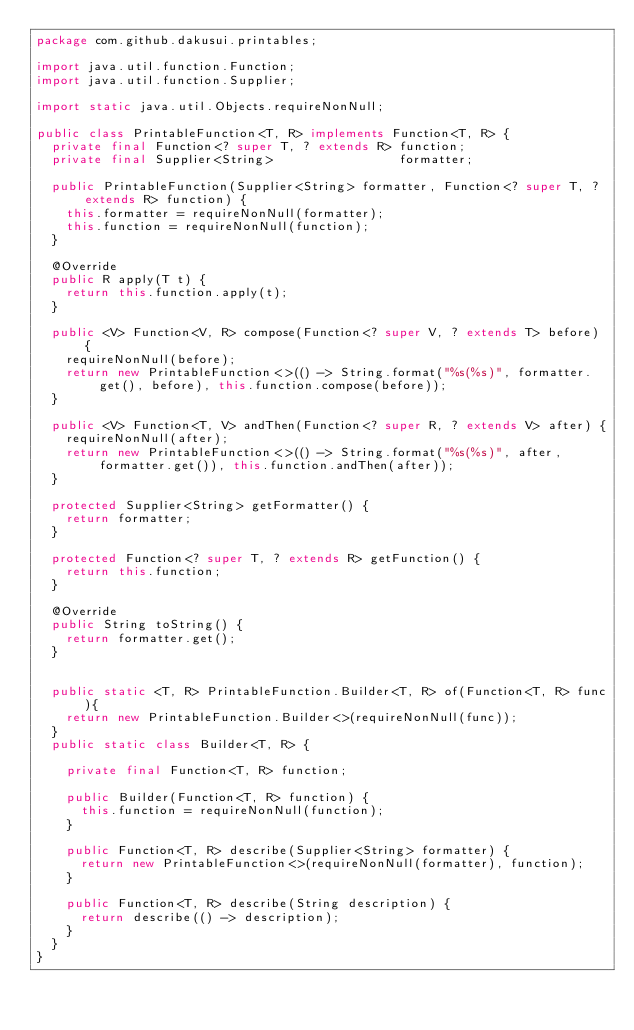<code> <loc_0><loc_0><loc_500><loc_500><_Java_>package com.github.dakusui.printables;

import java.util.function.Function;
import java.util.function.Supplier;

import static java.util.Objects.requireNonNull;

public class PrintableFunction<T, R> implements Function<T, R> {
  private final Function<? super T, ? extends R> function;
  private final Supplier<String>                 formatter;

  public PrintableFunction(Supplier<String> formatter, Function<? super T, ? extends R> function) {
    this.formatter = requireNonNull(formatter);
    this.function = requireNonNull(function);
  }

  @Override
  public R apply(T t) {
    return this.function.apply(t);
  }

  public <V> Function<V, R> compose(Function<? super V, ? extends T> before) {
    requireNonNull(before);
    return new PrintableFunction<>(() -> String.format("%s(%s)", formatter.get(), before), this.function.compose(before));
  }

  public <V> Function<T, V> andThen(Function<? super R, ? extends V> after) {
    requireNonNull(after);
    return new PrintableFunction<>(() -> String.format("%s(%s)", after, formatter.get()), this.function.andThen(after));
  }

  protected Supplier<String> getFormatter() {
    return formatter;
  }

  protected Function<? super T, ? extends R> getFunction() {
    return this.function;
  }

  @Override
  public String toString() {
    return formatter.get();
  }


  public static <T, R> PrintableFunction.Builder<T, R> of(Function<T, R> func){
    return new PrintableFunction.Builder<>(requireNonNull(func));
  }
  public static class Builder<T, R> {

    private final Function<T, R> function;

    public Builder(Function<T, R> function) {
      this.function = requireNonNull(function);
    }

    public Function<T, R> describe(Supplier<String> formatter) {
      return new PrintableFunction<>(requireNonNull(formatter), function);
    }

    public Function<T, R> describe(String description) {
      return describe(() -> description);
    }
  }
}
</code> 